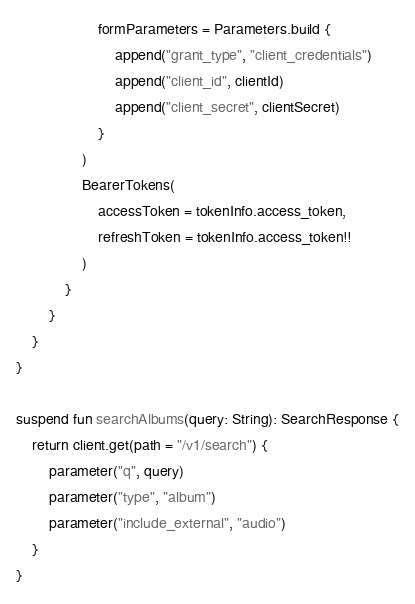Convert code to text. <code><loc_0><loc_0><loc_500><loc_500><_Kotlin_>                    formParameters = Parameters.build {
                        append("grant_type", "client_credentials")
                        append("client_id", clientId)
                        append("client_secret", clientSecret)
                    }
                )
                BearerTokens(
                    accessToken = tokenInfo.access_token,
                    refreshToken = tokenInfo.access_token!!
                )
            }
        }
    }
}

suspend fun searchAlbums(query: String): SearchResponse {
    return client.get(path = "/v1/search") {
        parameter("q", query)
        parameter("type", "album")
        parameter("include_external", "audio")
    }
}</code> 